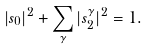Convert formula to latex. <formula><loc_0><loc_0><loc_500><loc_500>| s _ { 0 } | ^ { 2 } + \sum _ { \gamma } | s _ { 2 } ^ { \gamma } | ^ { 2 } = 1 .</formula> 